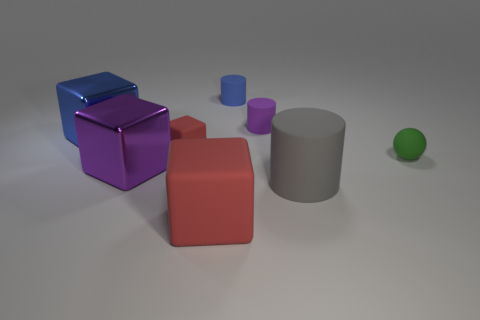How many tiny things are either green metal cubes or green things?
Give a very brief answer. 1. What number of other objects are there of the same color as the big rubber cube?
Ensure brevity in your answer.  1. What number of big blocks have the same material as the small purple object?
Your response must be concise. 1. There is a large block to the right of the big purple metallic block; is its color the same as the tiny matte cube?
Ensure brevity in your answer.  Yes. What number of gray things are either big objects or small rubber objects?
Your answer should be compact. 1. Do the big object on the right side of the blue cylinder and the small cube have the same material?
Provide a short and direct response. Yes. What number of things are blue blocks or purple objects that are to the left of the tiny purple cylinder?
Offer a very short reply. 2. How many tiny green rubber balls are to the right of the blue metallic thing left of the cylinder in front of the purple shiny cube?
Keep it short and to the point. 1. Does the blue object that is on the left side of the tiny red rubber cube have the same shape as the large purple object?
Give a very brief answer. Yes. There is a blue thing that is to the left of the tiny blue rubber thing; is there a tiny red matte object in front of it?
Provide a short and direct response. Yes. 